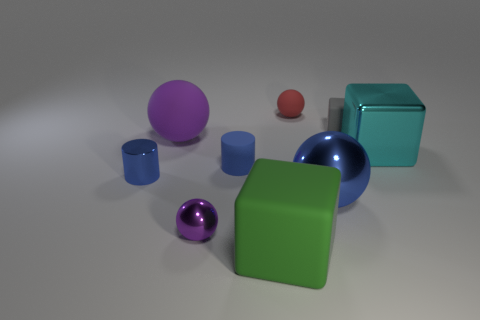Add 1 blue cylinders. How many objects exist? 10 Subtract all spheres. How many objects are left? 5 Subtract 0 green balls. How many objects are left? 9 Subtract all gray rubber cubes. Subtract all green things. How many objects are left? 7 Add 3 rubber cylinders. How many rubber cylinders are left? 4 Add 3 small purple balls. How many small purple balls exist? 4 